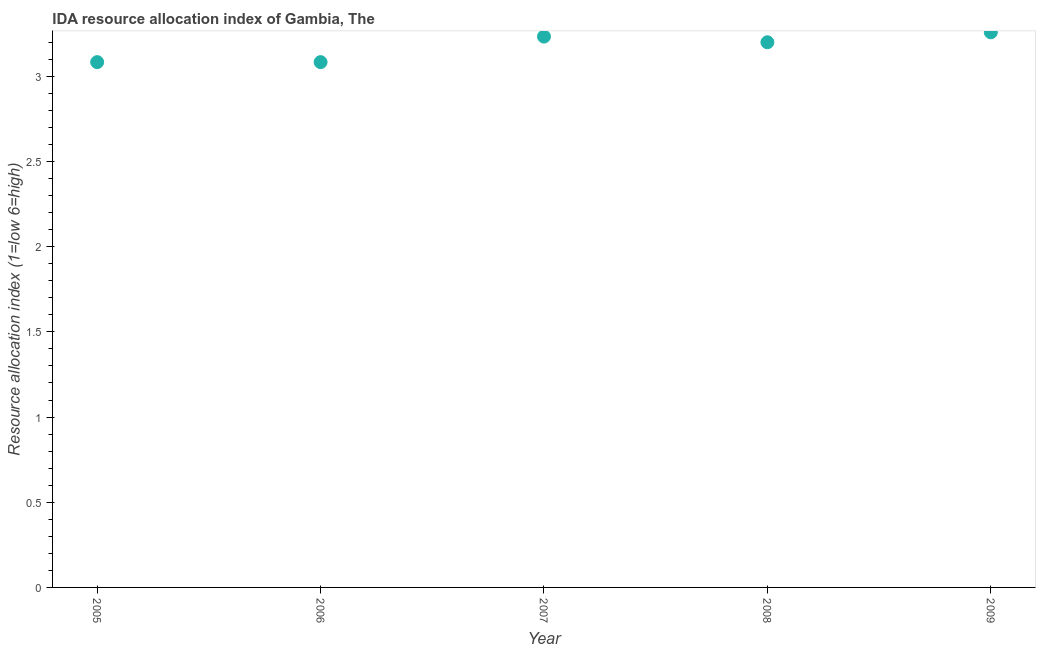What is the ida resource allocation index in 2007?
Offer a very short reply. 3.23. Across all years, what is the maximum ida resource allocation index?
Offer a terse response. 3.26. Across all years, what is the minimum ida resource allocation index?
Provide a succinct answer. 3.08. In which year was the ida resource allocation index maximum?
Your answer should be compact. 2009. In which year was the ida resource allocation index minimum?
Keep it short and to the point. 2005. What is the sum of the ida resource allocation index?
Provide a succinct answer. 15.86. What is the difference between the ida resource allocation index in 2005 and 2009?
Ensure brevity in your answer.  -0.18. What is the average ida resource allocation index per year?
Keep it short and to the point. 3.17. Do a majority of the years between 2005 and 2009 (inclusive) have ida resource allocation index greater than 1.3 ?
Your response must be concise. Yes. What is the ratio of the ida resource allocation index in 2007 to that in 2009?
Keep it short and to the point. 0.99. Is the ida resource allocation index in 2005 less than that in 2008?
Your answer should be compact. Yes. Is the difference between the ida resource allocation index in 2005 and 2008 greater than the difference between any two years?
Keep it short and to the point. No. What is the difference between the highest and the second highest ida resource allocation index?
Provide a succinct answer. 0.03. What is the difference between the highest and the lowest ida resource allocation index?
Your answer should be compact. 0.18. In how many years, is the ida resource allocation index greater than the average ida resource allocation index taken over all years?
Ensure brevity in your answer.  3. Does the ida resource allocation index monotonically increase over the years?
Provide a succinct answer. No. How many dotlines are there?
Provide a succinct answer. 1. Are the values on the major ticks of Y-axis written in scientific E-notation?
Keep it short and to the point. No. What is the title of the graph?
Provide a succinct answer. IDA resource allocation index of Gambia, The. What is the label or title of the Y-axis?
Offer a terse response. Resource allocation index (1=low 6=high). What is the Resource allocation index (1=low 6=high) in 2005?
Make the answer very short. 3.08. What is the Resource allocation index (1=low 6=high) in 2006?
Provide a succinct answer. 3.08. What is the Resource allocation index (1=low 6=high) in 2007?
Ensure brevity in your answer.  3.23. What is the Resource allocation index (1=low 6=high) in 2008?
Provide a succinct answer. 3.2. What is the Resource allocation index (1=low 6=high) in 2009?
Offer a very short reply. 3.26. What is the difference between the Resource allocation index (1=low 6=high) in 2005 and 2006?
Ensure brevity in your answer.  0. What is the difference between the Resource allocation index (1=low 6=high) in 2005 and 2008?
Your answer should be very brief. -0.12. What is the difference between the Resource allocation index (1=low 6=high) in 2005 and 2009?
Make the answer very short. -0.17. What is the difference between the Resource allocation index (1=low 6=high) in 2006 and 2008?
Offer a very short reply. -0.12. What is the difference between the Resource allocation index (1=low 6=high) in 2006 and 2009?
Offer a very short reply. -0.17. What is the difference between the Resource allocation index (1=low 6=high) in 2007 and 2008?
Ensure brevity in your answer.  0.03. What is the difference between the Resource allocation index (1=low 6=high) in 2007 and 2009?
Provide a succinct answer. -0.03. What is the difference between the Resource allocation index (1=low 6=high) in 2008 and 2009?
Your answer should be compact. -0.06. What is the ratio of the Resource allocation index (1=low 6=high) in 2005 to that in 2007?
Your response must be concise. 0.95. What is the ratio of the Resource allocation index (1=low 6=high) in 2005 to that in 2008?
Your answer should be compact. 0.96. What is the ratio of the Resource allocation index (1=low 6=high) in 2005 to that in 2009?
Ensure brevity in your answer.  0.95. What is the ratio of the Resource allocation index (1=low 6=high) in 2006 to that in 2007?
Ensure brevity in your answer.  0.95. What is the ratio of the Resource allocation index (1=low 6=high) in 2006 to that in 2009?
Offer a terse response. 0.95. What is the ratio of the Resource allocation index (1=low 6=high) in 2007 to that in 2009?
Offer a terse response. 0.99. 